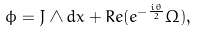<formula> <loc_0><loc_0><loc_500><loc_500>\phi = J \wedge d x + R e ( e ^ { - \frac { i \theta } { 2 } } \Omega ) ,</formula> 